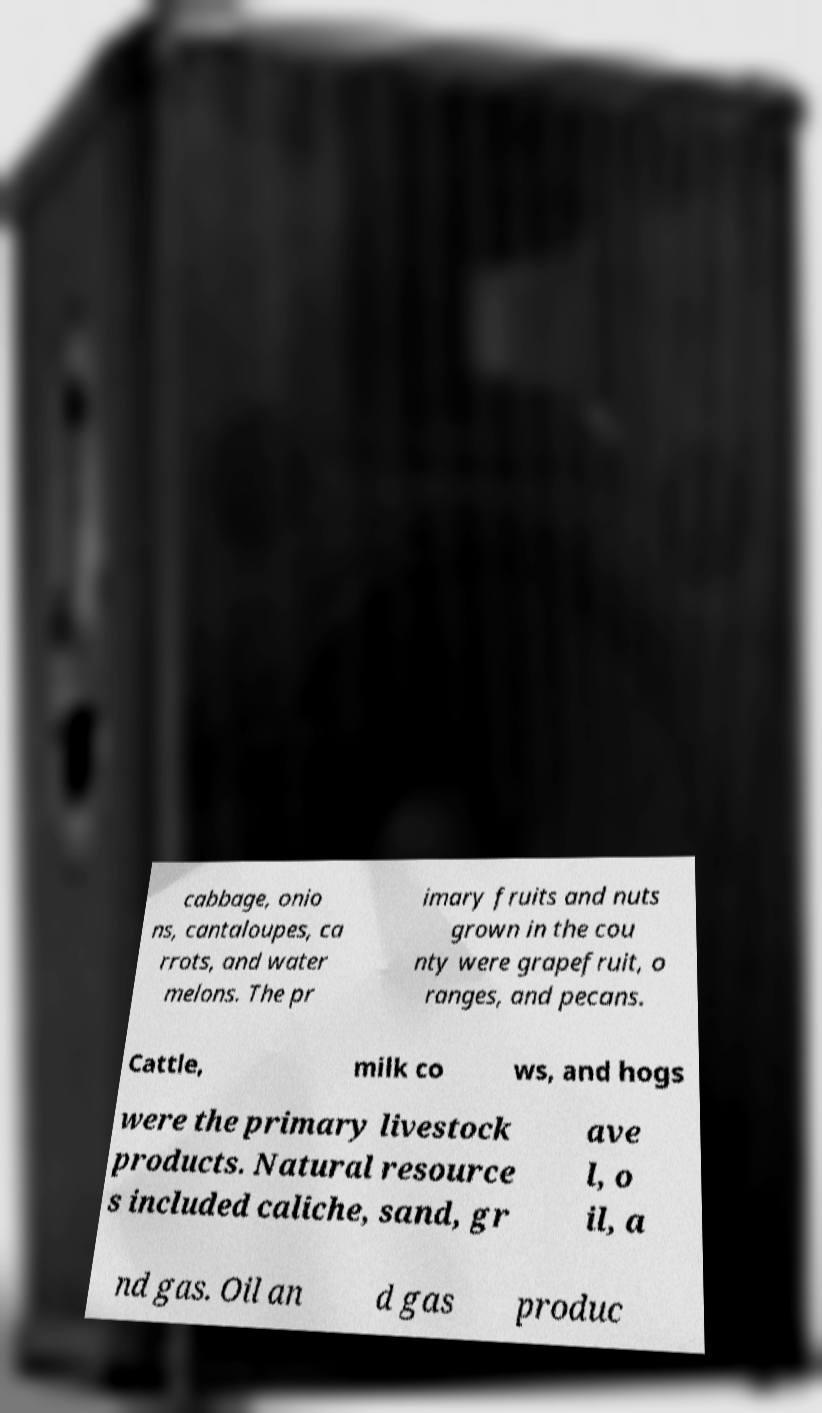Could you assist in decoding the text presented in this image and type it out clearly? cabbage, onio ns, cantaloupes, ca rrots, and water melons. The pr imary fruits and nuts grown in the cou nty were grapefruit, o ranges, and pecans. Cattle, milk co ws, and hogs were the primary livestock products. Natural resource s included caliche, sand, gr ave l, o il, a nd gas. Oil an d gas produc 